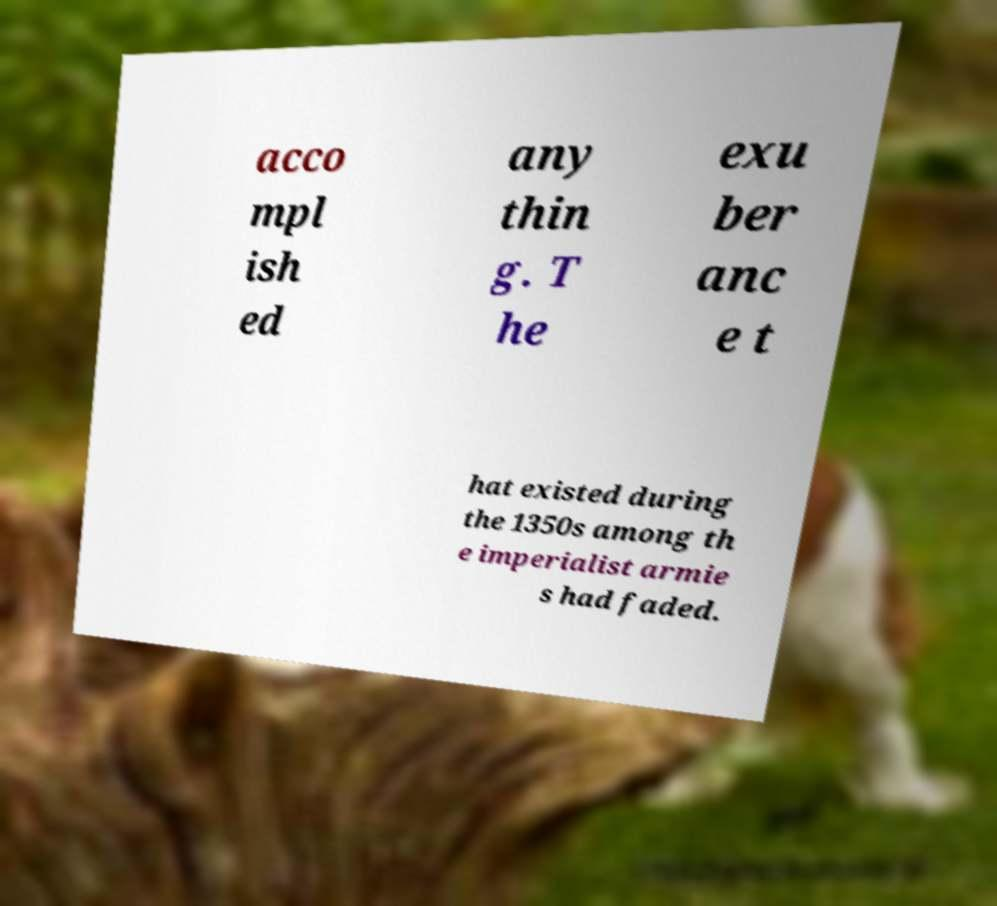Can you accurately transcribe the text from the provided image for me? acco mpl ish ed any thin g. T he exu ber anc e t hat existed during the 1350s among th e imperialist armie s had faded. 